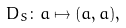<formula> <loc_0><loc_0><loc_500><loc_500>\ D _ { S } \colon a \mapsto ( a , a ) ,</formula> 